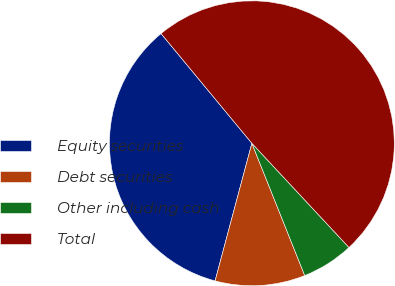<chart> <loc_0><loc_0><loc_500><loc_500><pie_chart><fcel>Equity securities<fcel>Debt securities<fcel>Other including cash<fcel>Total<nl><fcel>34.84%<fcel>10.21%<fcel>5.89%<fcel>49.07%<nl></chart> 